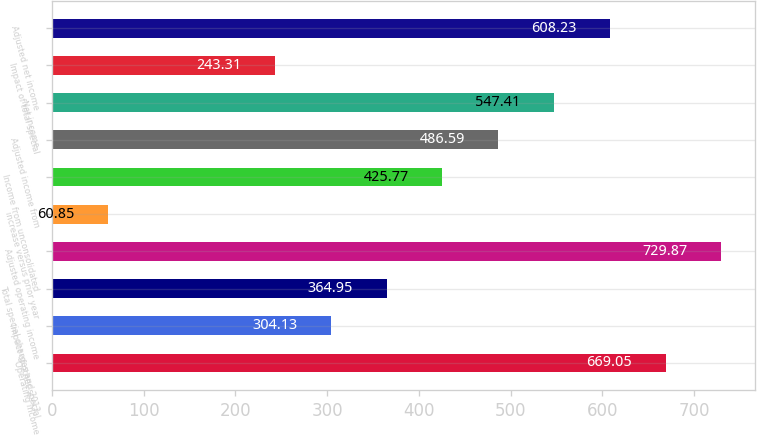Convert chart to OTSL. <chart><loc_0><loc_0><loc_500><loc_500><bar_chart><fcel>Operating income<fcel>Impact of other special<fcel>Total special charges and 2013<fcel>Adjusted operating income<fcel>increase versus prior year<fcel>Income from unconsolidated<fcel>Adjusted income from<fcel>Net income<fcel>Impact of total special<fcel>Adjusted net income<nl><fcel>669.05<fcel>304.13<fcel>364.95<fcel>729.87<fcel>60.85<fcel>425.77<fcel>486.59<fcel>547.41<fcel>243.31<fcel>608.23<nl></chart> 